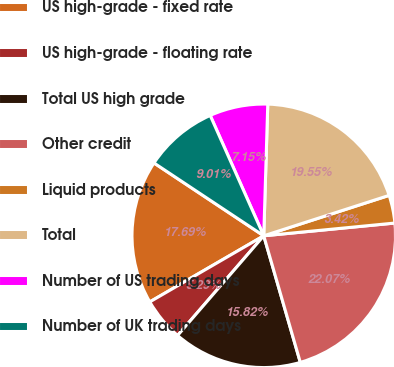Convert chart to OTSL. <chart><loc_0><loc_0><loc_500><loc_500><pie_chart><fcel>US high-grade - fixed rate<fcel>US high-grade - floating rate<fcel>Total US high grade<fcel>Other credit<fcel>Liquid products<fcel>Total<fcel>Number of US trading days<fcel>Number of UK trading days<nl><fcel>17.69%<fcel>5.29%<fcel>15.82%<fcel>22.07%<fcel>3.42%<fcel>19.55%<fcel>7.15%<fcel>9.01%<nl></chart> 